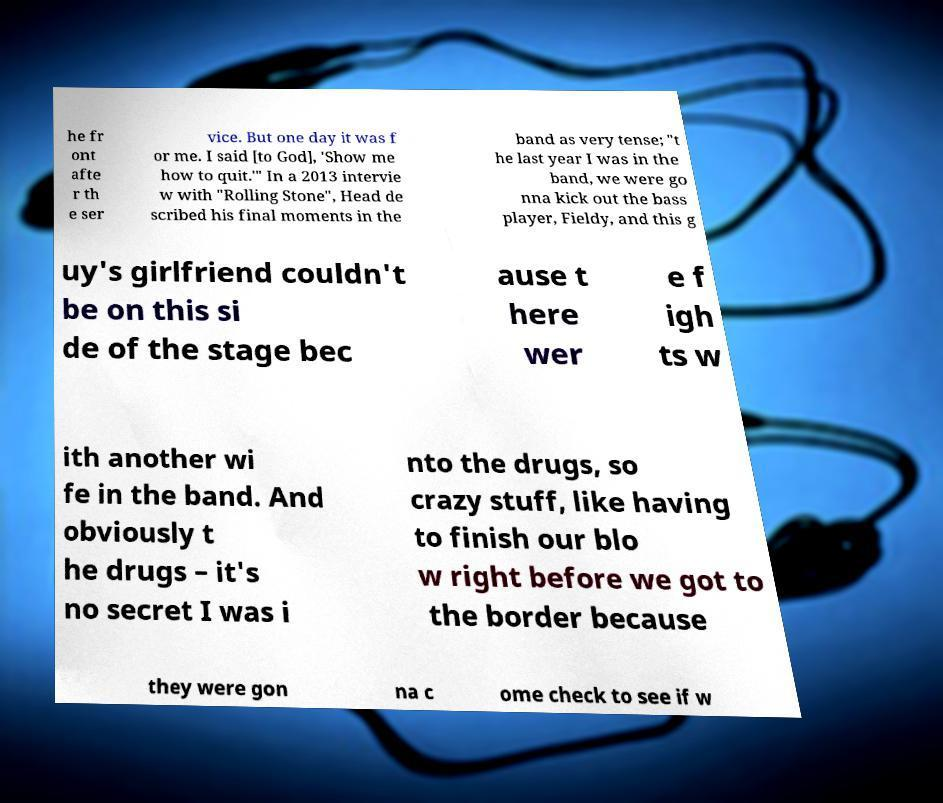Could you extract and type out the text from this image? he fr ont afte r th e ser vice. But one day it was f or me. I said [to God], 'Show me how to quit.'" In a 2013 intervie w with "Rolling Stone", Head de scribed his final moments in the band as very tense; "t he last year I was in the band, we were go nna kick out the bass player, Fieldy, and this g uy's girlfriend couldn't be on this si de of the stage bec ause t here wer e f igh ts w ith another wi fe in the band. And obviously t he drugs – it's no secret I was i nto the drugs, so crazy stuff, like having to finish our blo w right before we got to the border because they were gon na c ome check to see if w 